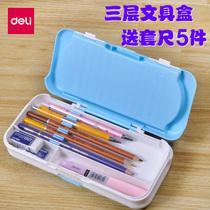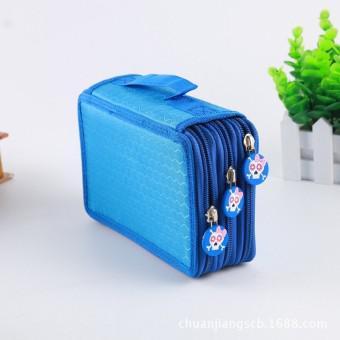The first image is the image on the left, the second image is the image on the right. Assess this claim about the two images: "Each image only contains one showcased item". Correct or not? Answer yes or no. Yes. The first image is the image on the left, the second image is the image on the right. For the images shown, is this caption "At least one of the cases is closed." true? Answer yes or no. Yes. 